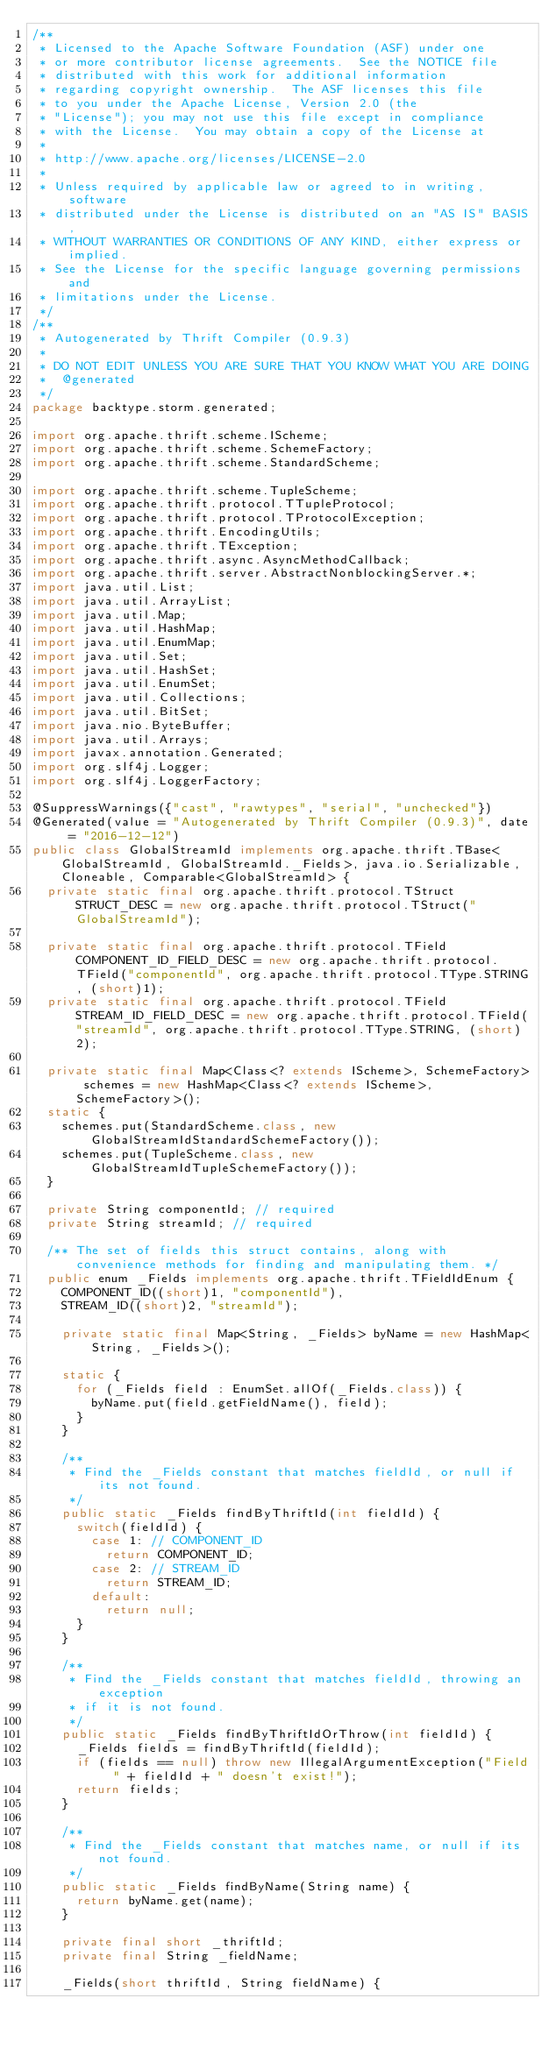<code> <loc_0><loc_0><loc_500><loc_500><_Java_>/**
 * Licensed to the Apache Software Foundation (ASF) under one
 * or more contributor license agreements.  See the NOTICE file
 * distributed with this work for additional information
 * regarding copyright ownership.  The ASF licenses this file
 * to you under the Apache License, Version 2.0 (the
 * "License"); you may not use this file except in compliance
 * with the License.  You may obtain a copy of the License at
 *
 * http://www.apache.org/licenses/LICENSE-2.0
 *
 * Unless required by applicable law or agreed to in writing, software
 * distributed under the License is distributed on an "AS IS" BASIS,
 * WITHOUT WARRANTIES OR CONDITIONS OF ANY KIND, either express or implied.
 * See the License for the specific language governing permissions and
 * limitations under the License.
 */
/**
 * Autogenerated by Thrift Compiler (0.9.3)
 *
 * DO NOT EDIT UNLESS YOU ARE SURE THAT YOU KNOW WHAT YOU ARE DOING
 *  @generated
 */
package backtype.storm.generated;

import org.apache.thrift.scheme.IScheme;
import org.apache.thrift.scheme.SchemeFactory;
import org.apache.thrift.scheme.StandardScheme;

import org.apache.thrift.scheme.TupleScheme;
import org.apache.thrift.protocol.TTupleProtocol;
import org.apache.thrift.protocol.TProtocolException;
import org.apache.thrift.EncodingUtils;
import org.apache.thrift.TException;
import org.apache.thrift.async.AsyncMethodCallback;
import org.apache.thrift.server.AbstractNonblockingServer.*;
import java.util.List;
import java.util.ArrayList;
import java.util.Map;
import java.util.HashMap;
import java.util.EnumMap;
import java.util.Set;
import java.util.HashSet;
import java.util.EnumSet;
import java.util.Collections;
import java.util.BitSet;
import java.nio.ByteBuffer;
import java.util.Arrays;
import javax.annotation.Generated;
import org.slf4j.Logger;
import org.slf4j.LoggerFactory;

@SuppressWarnings({"cast", "rawtypes", "serial", "unchecked"})
@Generated(value = "Autogenerated by Thrift Compiler (0.9.3)", date = "2016-12-12")
public class GlobalStreamId implements org.apache.thrift.TBase<GlobalStreamId, GlobalStreamId._Fields>, java.io.Serializable, Cloneable, Comparable<GlobalStreamId> {
  private static final org.apache.thrift.protocol.TStruct STRUCT_DESC = new org.apache.thrift.protocol.TStruct("GlobalStreamId");

  private static final org.apache.thrift.protocol.TField COMPONENT_ID_FIELD_DESC = new org.apache.thrift.protocol.TField("componentId", org.apache.thrift.protocol.TType.STRING, (short)1);
  private static final org.apache.thrift.protocol.TField STREAM_ID_FIELD_DESC = new org.apache.thrift.protocol.TField("streamId", org.apache.thrift.protocol.TType.STRING, (short)2);

  private static final Map<Class<? extends IScheme>, SchemeFactory> schemes = new HashMap<Class<? extends IScheme>, SchemeFactory>();
  static {
    schemes.put(StandardScheme.class, new GlobalStreamIdStandardSchemeFactory());
    schemes.put(TupleScheme.class, new GlobalStreamIdTupleSchemeFactory());
  }

  private String componentId; // required
  private String streamId; // required

  /** The set of fields this struct contains, along with convenience methods for finding and manipulating them. */
  public enum _Fields implements org.apache.thrift.TFieldIdEnum {
    COMPONENT_ID((short)1, "componentId"),
    STREAM_ID((short)2, "streamId");

    private static final Map<String, _Fields> byName = new HashMap<String, _Fields>();

    static {
      for (_Fields field : EnumSet.allOf(_Fields.class)) {
        byName.put(field.getFieldName(), field);
      }
    }

    /**
     * Find the _Fields constant that matches fieldId, or null if its not found.
     */
    public static _Fields findByThriftId(int fieldId) {
      switch(fieldId) {
        case 1: // COMPONENT_ID
          return COMPONENT_ID;
        case 2: // STREAM_ID
          return STREAM_ID;
        default:
          return null;
      }
    }

    /**
     * Find the _Fields constant that matches fieldId, throwing an exception
     * if it is not found.
     */
    public static _Fields findByThriftIdOrThrow(int fieldId) {
      _Fields fields = findByThriftId(fieldId);
      if (fields == null) throw new IllegalArgumentException("Field " + fieldId + " doesn't exist!");
      return fields;
    }

    /**
     * Find the _Fields constant that matches name, or null if its not found.
     */
    public static _Fields findByName(String name) {
      return byName.get(name);
    }

    private final short _thriftId;
    private final String _fieldName;

    _Fields(short thriftId, String fieldName) {</code> 